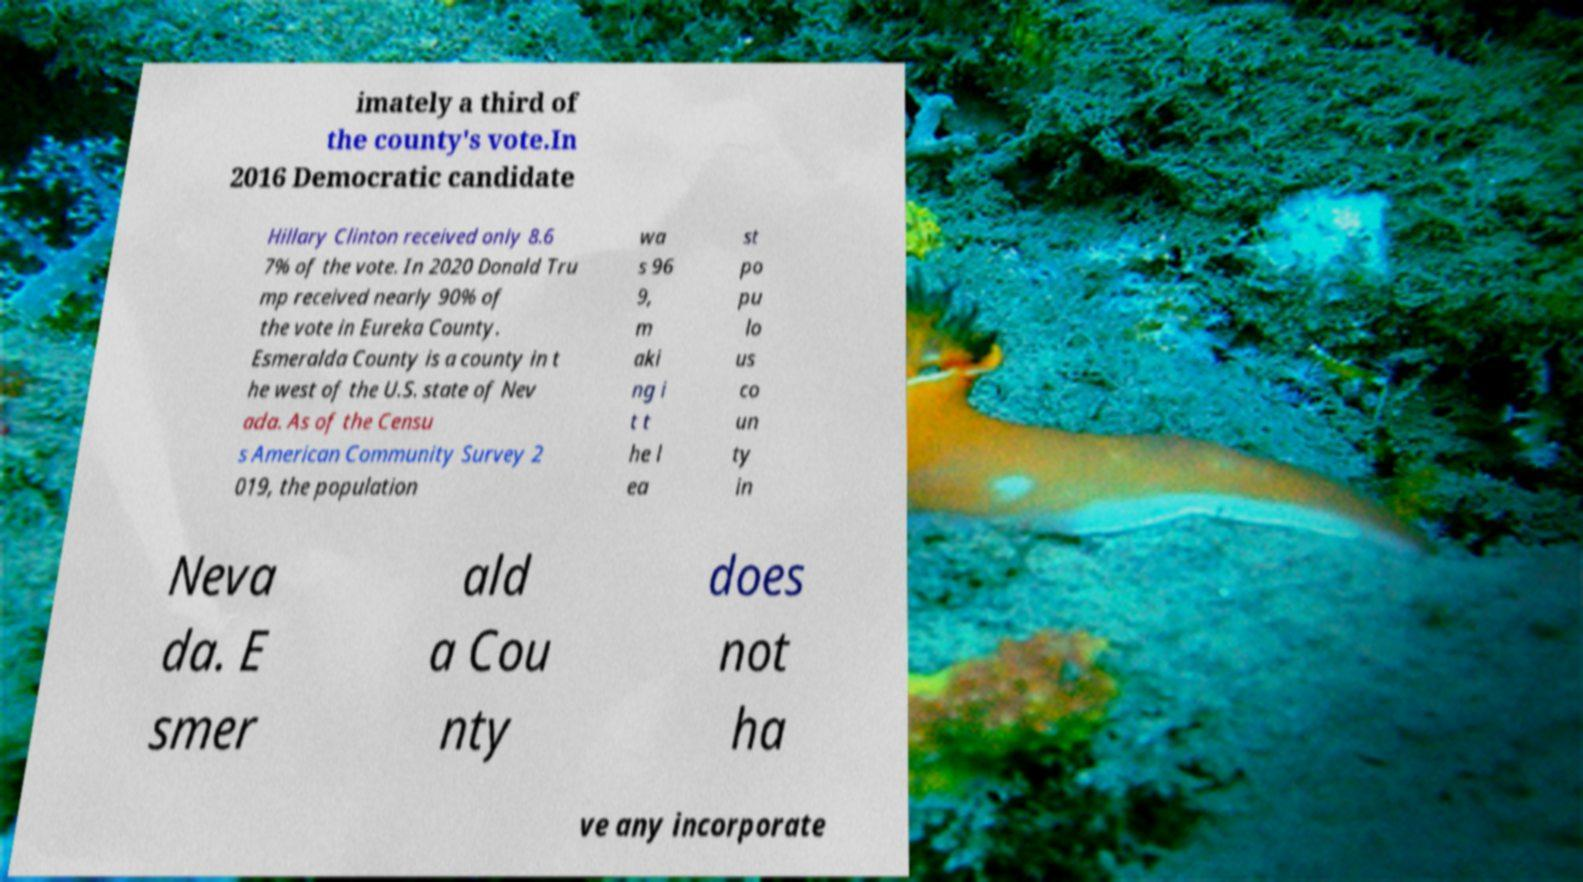For documentation purposes, I need the text within this image transcribed. Could you provide that? imately a third of the county's vote.In 2016 Democratic candidate Hillary Clinton received only 8.6 7% of the vote. In 2020 Donald Tru mp received nearly 90% of the vote in Eureka County. Esmeralda County is a county in t he west of the U.S. state of Nev ada. As of the Censu s American Community Survey 2 019, the population wa s 96 9, m aki ng i t t he l ea st po pu lo us co un ty in Neva da. E smer ald a Cou nty does not ha ve any incorporate 